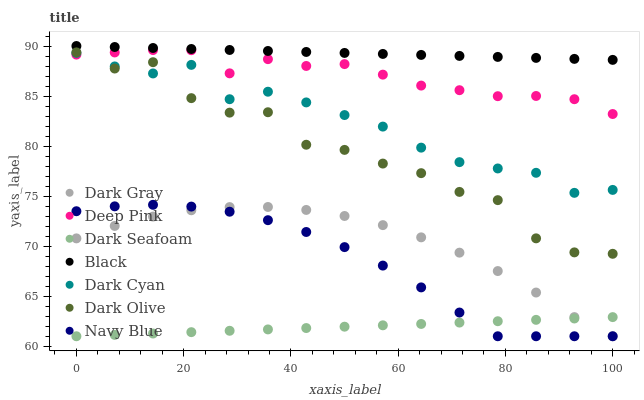Does Dark Seafoam have the minimum area under the curve?
Answer yes or no. Yes. Does Black have the maximum area under the curve?
Answer yes or no. Yes. Does Navy Blue have the minimum area under the curve?
Answer yes or no. No. Does Navy Blue have the maximum area under the curve?
Answer yes or no. No. Is Black the smoothest?
Answer yes or no. Yes. Is Dark Olive the roughest?
Answer yes or no. Yes. Is Navy Blue the smoothest?
Answer yes or no. No. Is Navy Blue the roughest?
Answer yes or no. No. Does Navy Blue have the lowest value?
Answer yes or no. Yes. Does Dark Olive have the lowest value?
Answer yes or no. No. Does Black have the highest value?
Answer yes or no. Yes. Does Navy Blue have the highest value?
Answer yes or no. No. Is Dark Seafoam less than Deep Pink?
Answer yes or no. Yes. Is Deep Pink greater than Dark Seafoam?
Answer yes or no. Yes. Does Dark Cyan intersect Dark Olive?
Answer yes or no. Yes. Is Dark Cyan less than Dark Olive?
Answer yes or no. No. Is Dark Cyan greater than Dark Olive?
Answer yes or no. No. Does Dark Seafoam intersect Deep Pink?
Answer yes or no. No. 